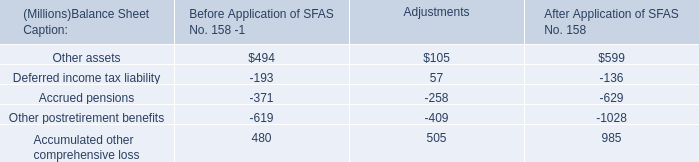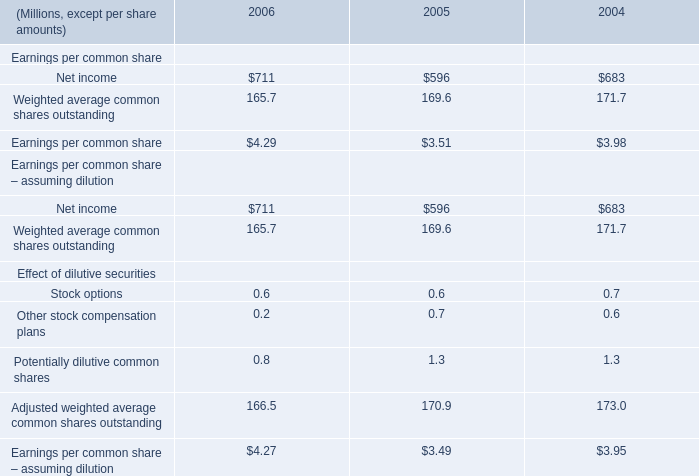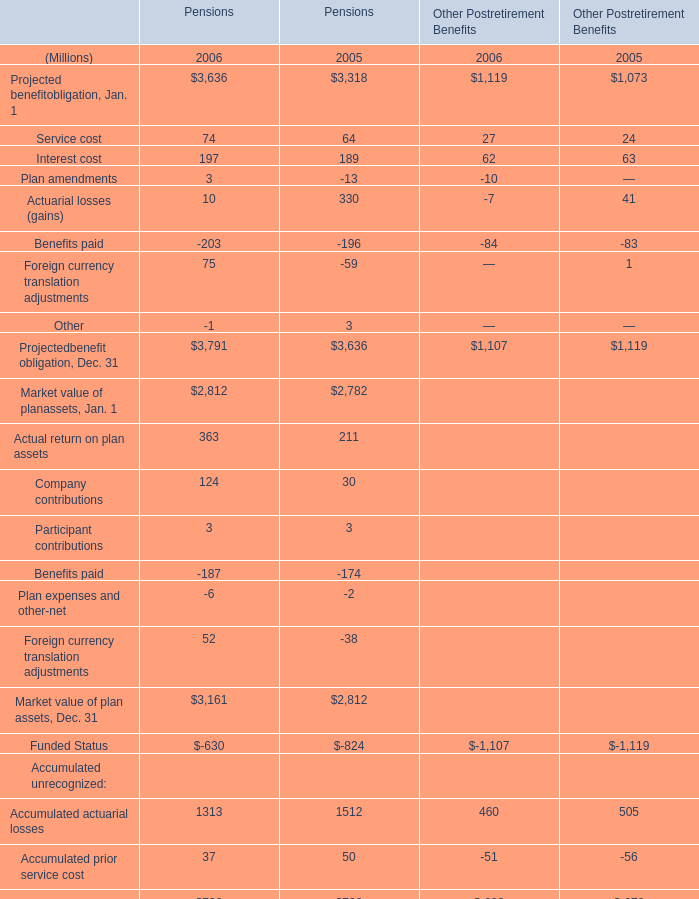what's the total amount of Market value of planassets, Jan. 1 of Pensions 2005, and Other postretirement benefits of After Application of SFAS No. 158 ? 
Computations: (2782.0 + 1028.0)
Answer: 3810.0. 